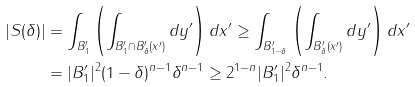<formula> <loc_0><loc_0><loc_500><loc_500>| S ( \delta ) | & = \int _ { B _ { 1 } ^ { \prime } } \left ( \int _ { B _ { 1 } ^ { \prime } \cap B _ { \delta } ^ { \prime } ( x ^ { \prime } ) } d y ^ { \prime } \right ) d x ^ { \prime } \geq \int _ { B _ { 1 - \delta } ^ { \prime } } \left ( \int _ { B _ { \delta } ^ { \prime } ( x ^ { \prime } ) } d y ^ { \prime } \right ) d x ^ { \prime } \\ & = | B _ { 1 } ^ { \prime } | ^ { 2 } ( 1 - \delta ) ^ { n - 1 } \delta ^ { n - 1 } \geq 2 ^ { 1 - n } | B _ { 1 } ^ { \prime } | ^ { 2 } \delta ^ { n - 1 } .</formula> 